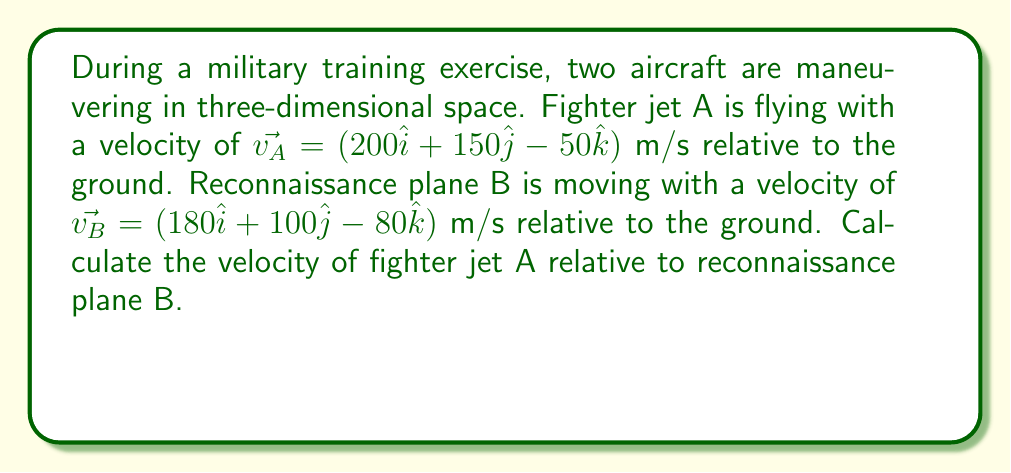Can you solve this math problem? To find the velocity of fighter jet A relative to reconnaissance plane B, we need to use the concept of relative velocity in three-dimensional space. The relative velocity is calculated by subtracting the velocity of the reference object (plane B) from the velocity of the object of interest (jet A).

Let's denote the relative velocity as $\vec{v_{A/B}}$, which represents the velocity of A with respect to B.

The formula for relative velocity is:
$$\vec{v_{A/B}} = \vec{v_A} - \vec{v_B}$$

Step 1: Substitute the given velocities into the formula.
$$\vec{v_{A/B}} = (200\hat{i} + 150\hat{j} - 50\hat{k}) - (180\hat{i} + 100\hat{j} - 80\hat{k})$$

Step 2: Subtract the corresponding components.
$$\vec{v_{A/B}} = (200 - 180)\hat{i} + (150 - 100)\hat{j} + (-50 - (-80))\hat{k}$$

Step 3: Simplify the expression.
$$\vec{v_{A/B}} = 20\hat{i} + 50\hat{j} + 30\hat{k}$$

Therefore, the velocity of fighter jet A relative to reconnaissance plane B is $20\hat{i} + 50\hat{j} + 30\hat{k}$ m/s.
Answer: $\vec{v_{A/B}} = 20\hat{i} + 50\hat{j} + 30\hat{k}$ m/s 